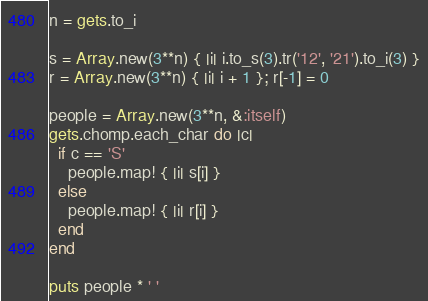<code> <loc_0><loc_0><loc_500><loc_500><_Ruby_>n = gets.to_i

s = Array.new(3**n) { |i| i.to_s(3).tr('12', '21').to_i(3) }
r = Array.new(3**n) { |i| i + 1 }; r[-1] = 0

people = Array.new(3**n, &:itself)
gets.chomp.each_char do |c|
  if c == 'S'
    people.map! { |i| s[i] }
  else
    people.map! { |i| r[i] }
  end
end

puts people * ' '
</code> 